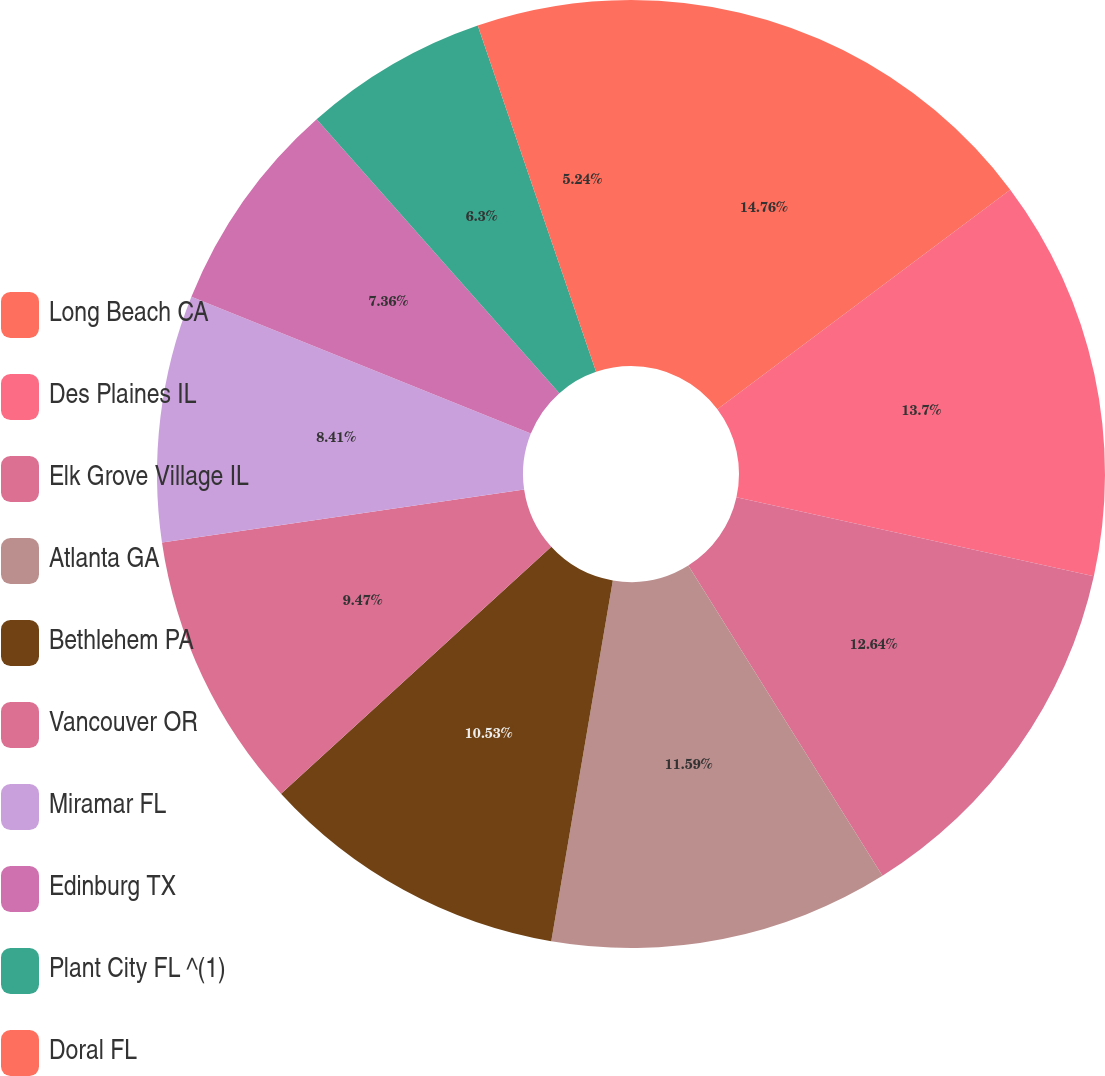<chart> <loc_0><loc_0><loc_500><loc_500><pie_chart><fcel>Long Beach CA<fcel>Des Plaines IL<fcel>Elk Grove Village IL<fcel>Atlanta GA<fcel>Bethlehem PA<fcel>Vancouver OR<fcel>Miramar FL<fcel>Edinburg TX<fcel>Plant City FL ^(1)<fcel>Doral FL<nl><fcel>14.76%<fcel>13.7%<fcel>12.64%<fcel>11.59%<fcel>10.53%<fcel>9.47%<fcel>8.41%<fcel>7.36%<fcel>6.3%<fcel>5.24%<nl></chart> 